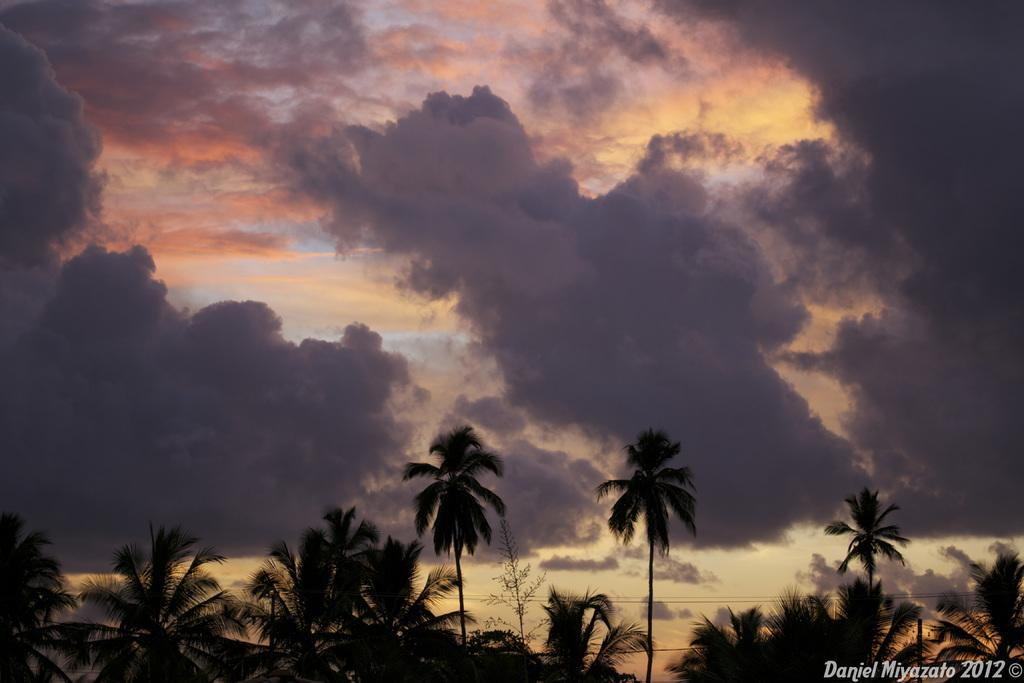What can be seen in the sky in the image? There are clouds in the sky in the image. What type of man-made structures are visible in the image? Transmission wires are visible in the image. What type of natural elements are present in the image? Trees are present in the image. Is there any text or marking in the image? Yes, there is a watermark in the bottom right corner of the image. What type of anger can be seen on the faces of the crowd in the image? There is no crowd present in the image, and therefore no anger can be observed. What type of sofa is visible in the image? There is no sofa present in the image. 